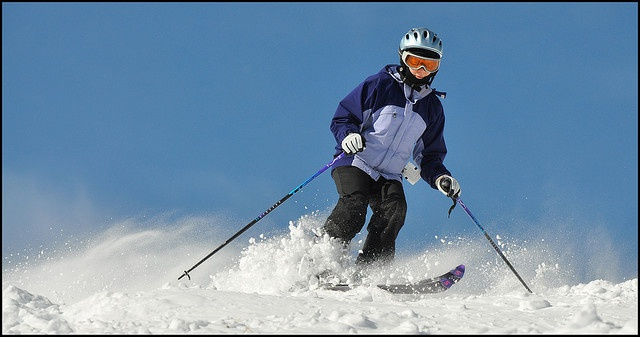Describe the objects in this image and their specific colors. I can see people in black, gray, and darkgray tones and skis in black, darkgray, gray, lightgray, and purple tones in this image. 